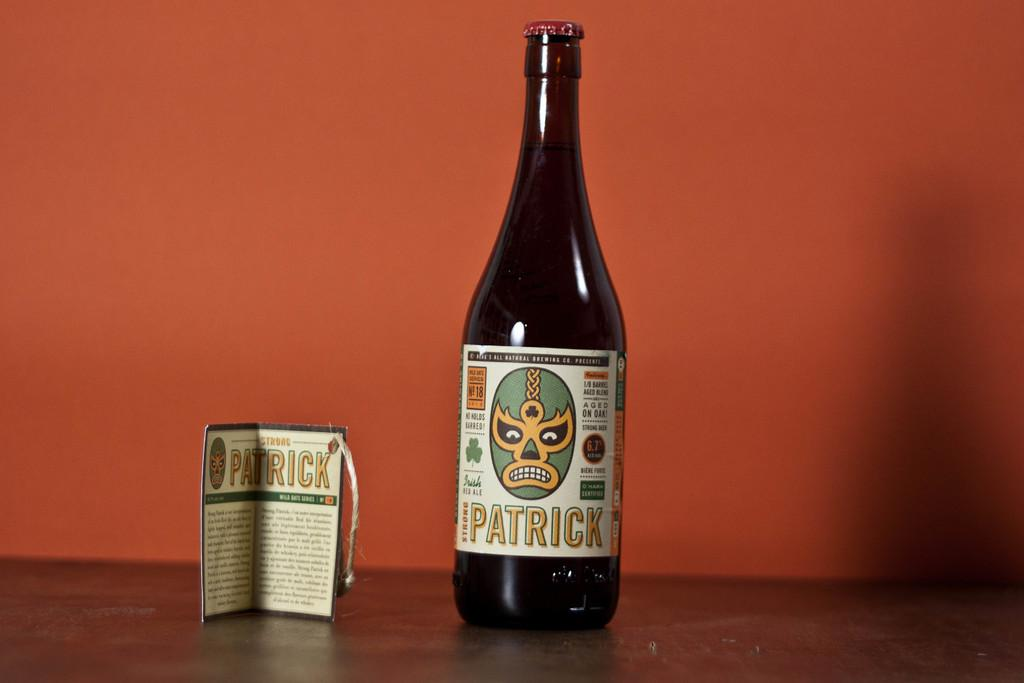<image>
Offer a succinct explanation of the picture presented. A bottle of wine with Patrick on the label along with a phamplet about the wine 